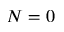<formula> <loc_0><loc_0><loc_500><loc_500>N = 0</formula> 